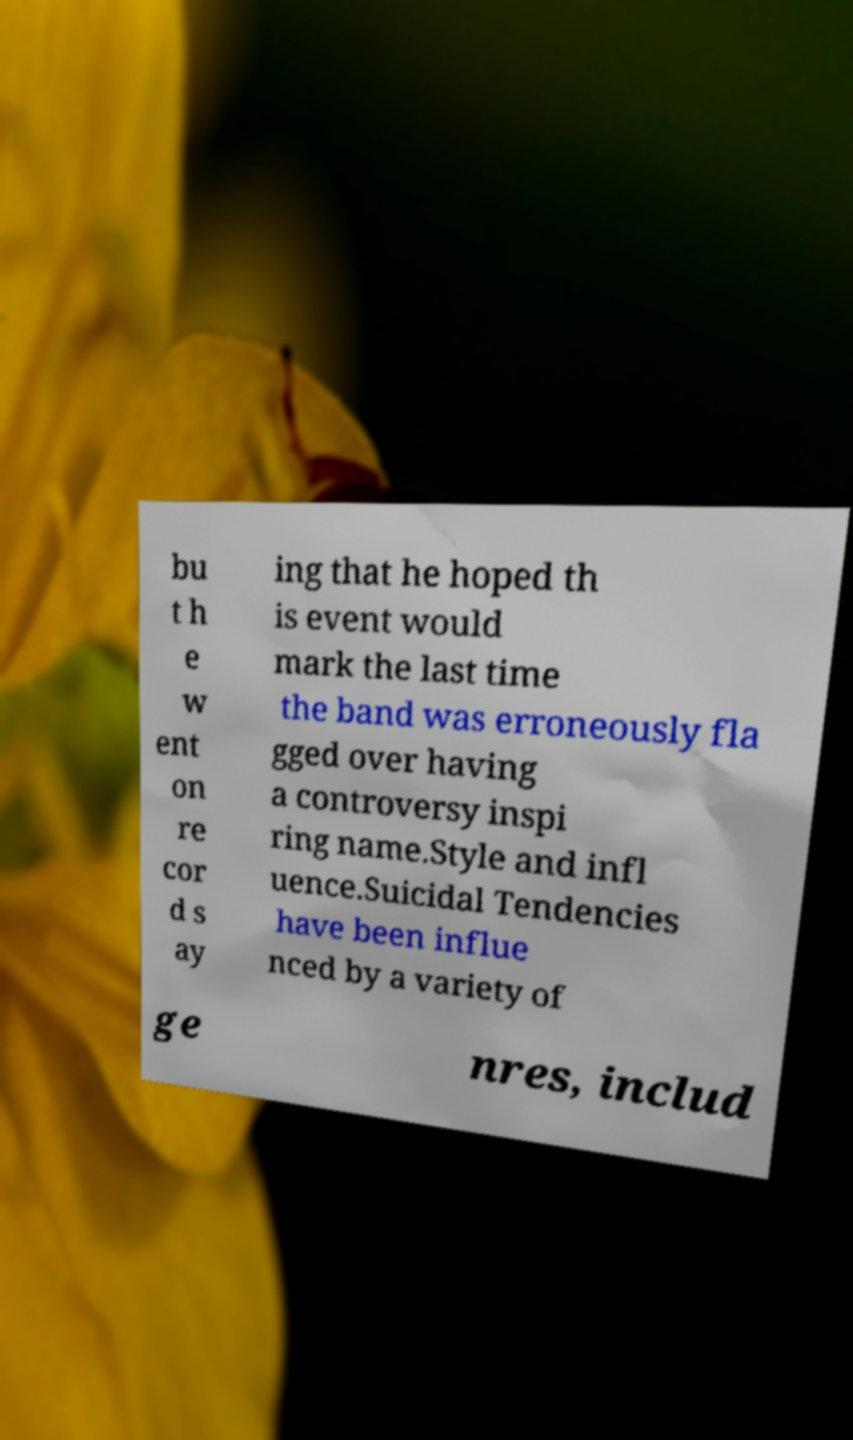I need the written content from this picture converted into text. Can you do that? bu t h e w ent on re cor d s ay ing that he hoped th is event would mark the last time the band was erroneously fla gged over having a controversy inspi ring name.Style and infl uence.Suicidal Tendencies have been influe nced by a variety of ge nres, includ 